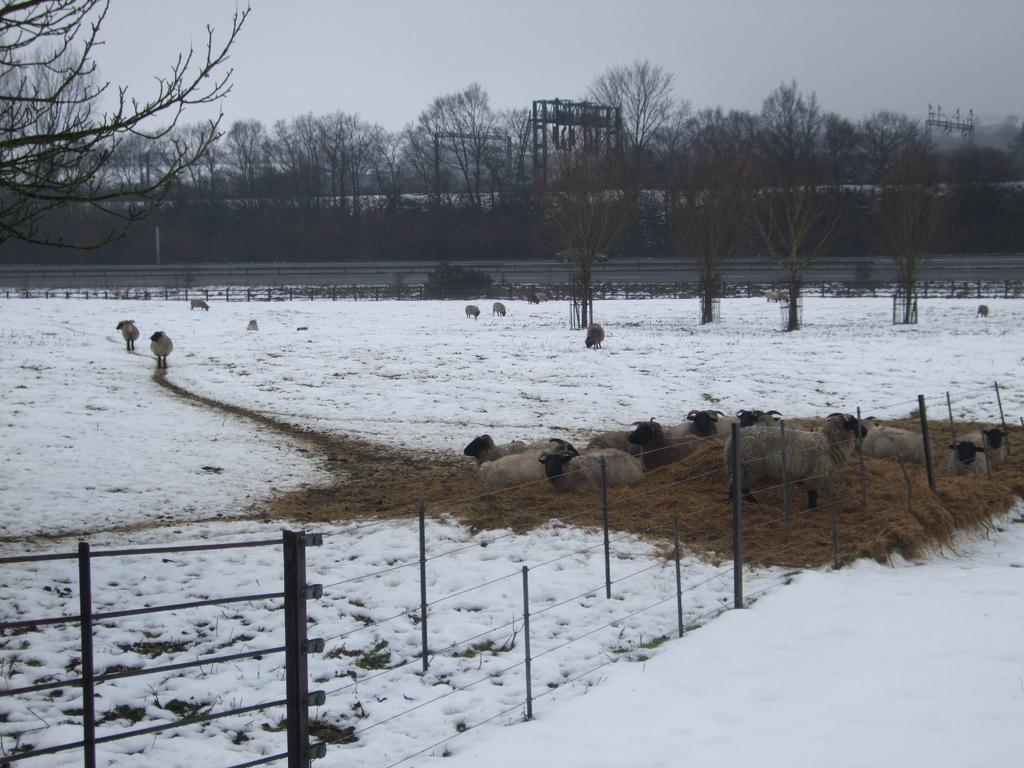What animals can be seen in the image? There are sheeps in the image. What type of terrain are the sheeps on? The sheeps are on grass and snow. What is the purpose of the structure in the image? There is a fence in the image, which might serve as a boundary or enclosure. What type of vegetation is present in the image? There are trees in the image. What can be seen in the background of the image? The sky is visible in the background of the image. How many icicles are hanging from the trees in the image? There are no icicles present in the image; the trees are not covered in ice. What direction is the wind blowing in the image? There is no indication of wind direction in the image, as there are no visible objects or effects that would suggest wind. 